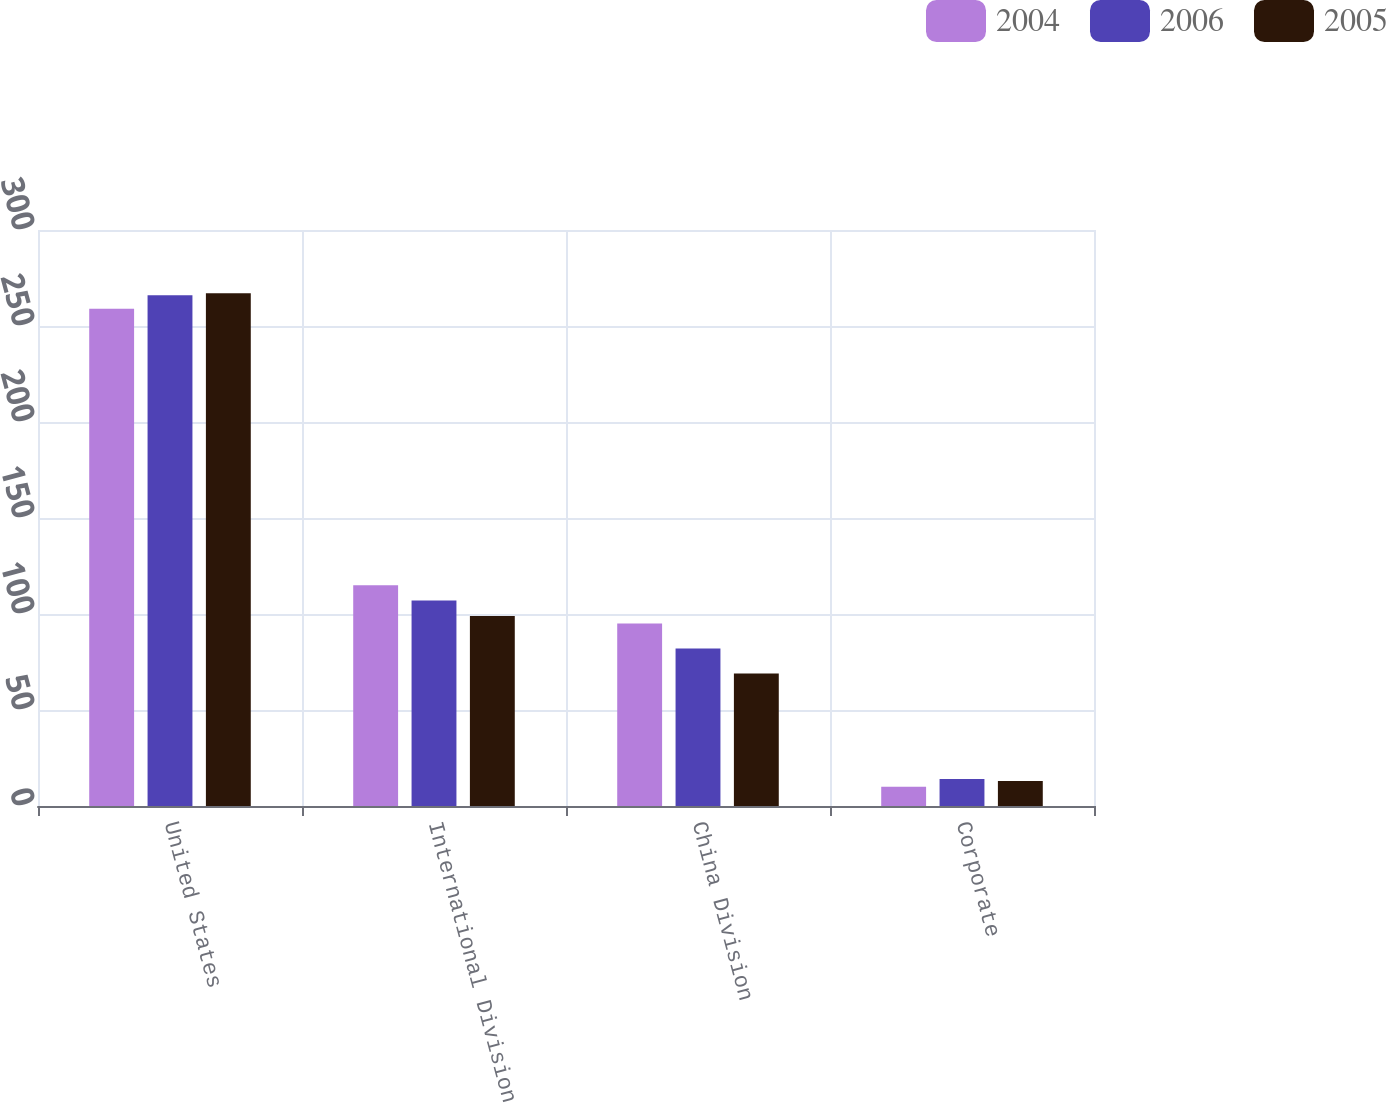Convert chart. <chart><loc_0><loc_0><loc_500><loc_500><stacked_bar_chart><ecel><fcel>United States<fcel>International Division<fcel>China Division<fcel>Corporate<nl><fcel>2004<fcel>259<fcel>115<fcel>95<fcel>10<nl><fcel>2006<fcel>266<fcel>107<fcel>82<fcel>14<nl><fcel>2005<fcel>267<fcel>99<fcel>69<fcel>13<nl></chart> 